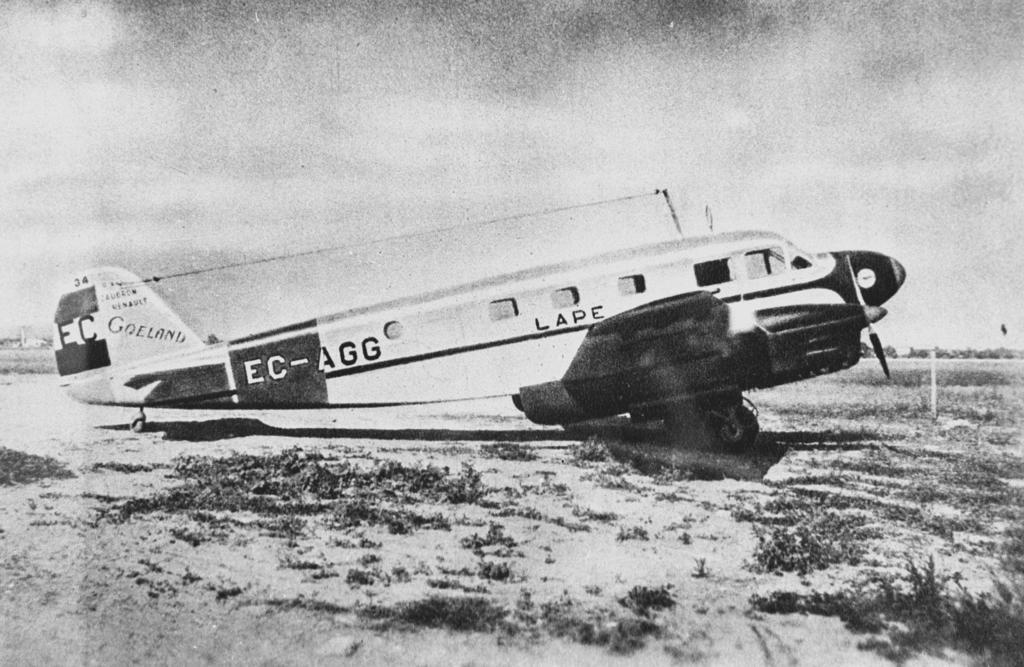<image>
Present a compact description of the photo's key features. The EC-AGG Goeland water airplane taking off from the water. 